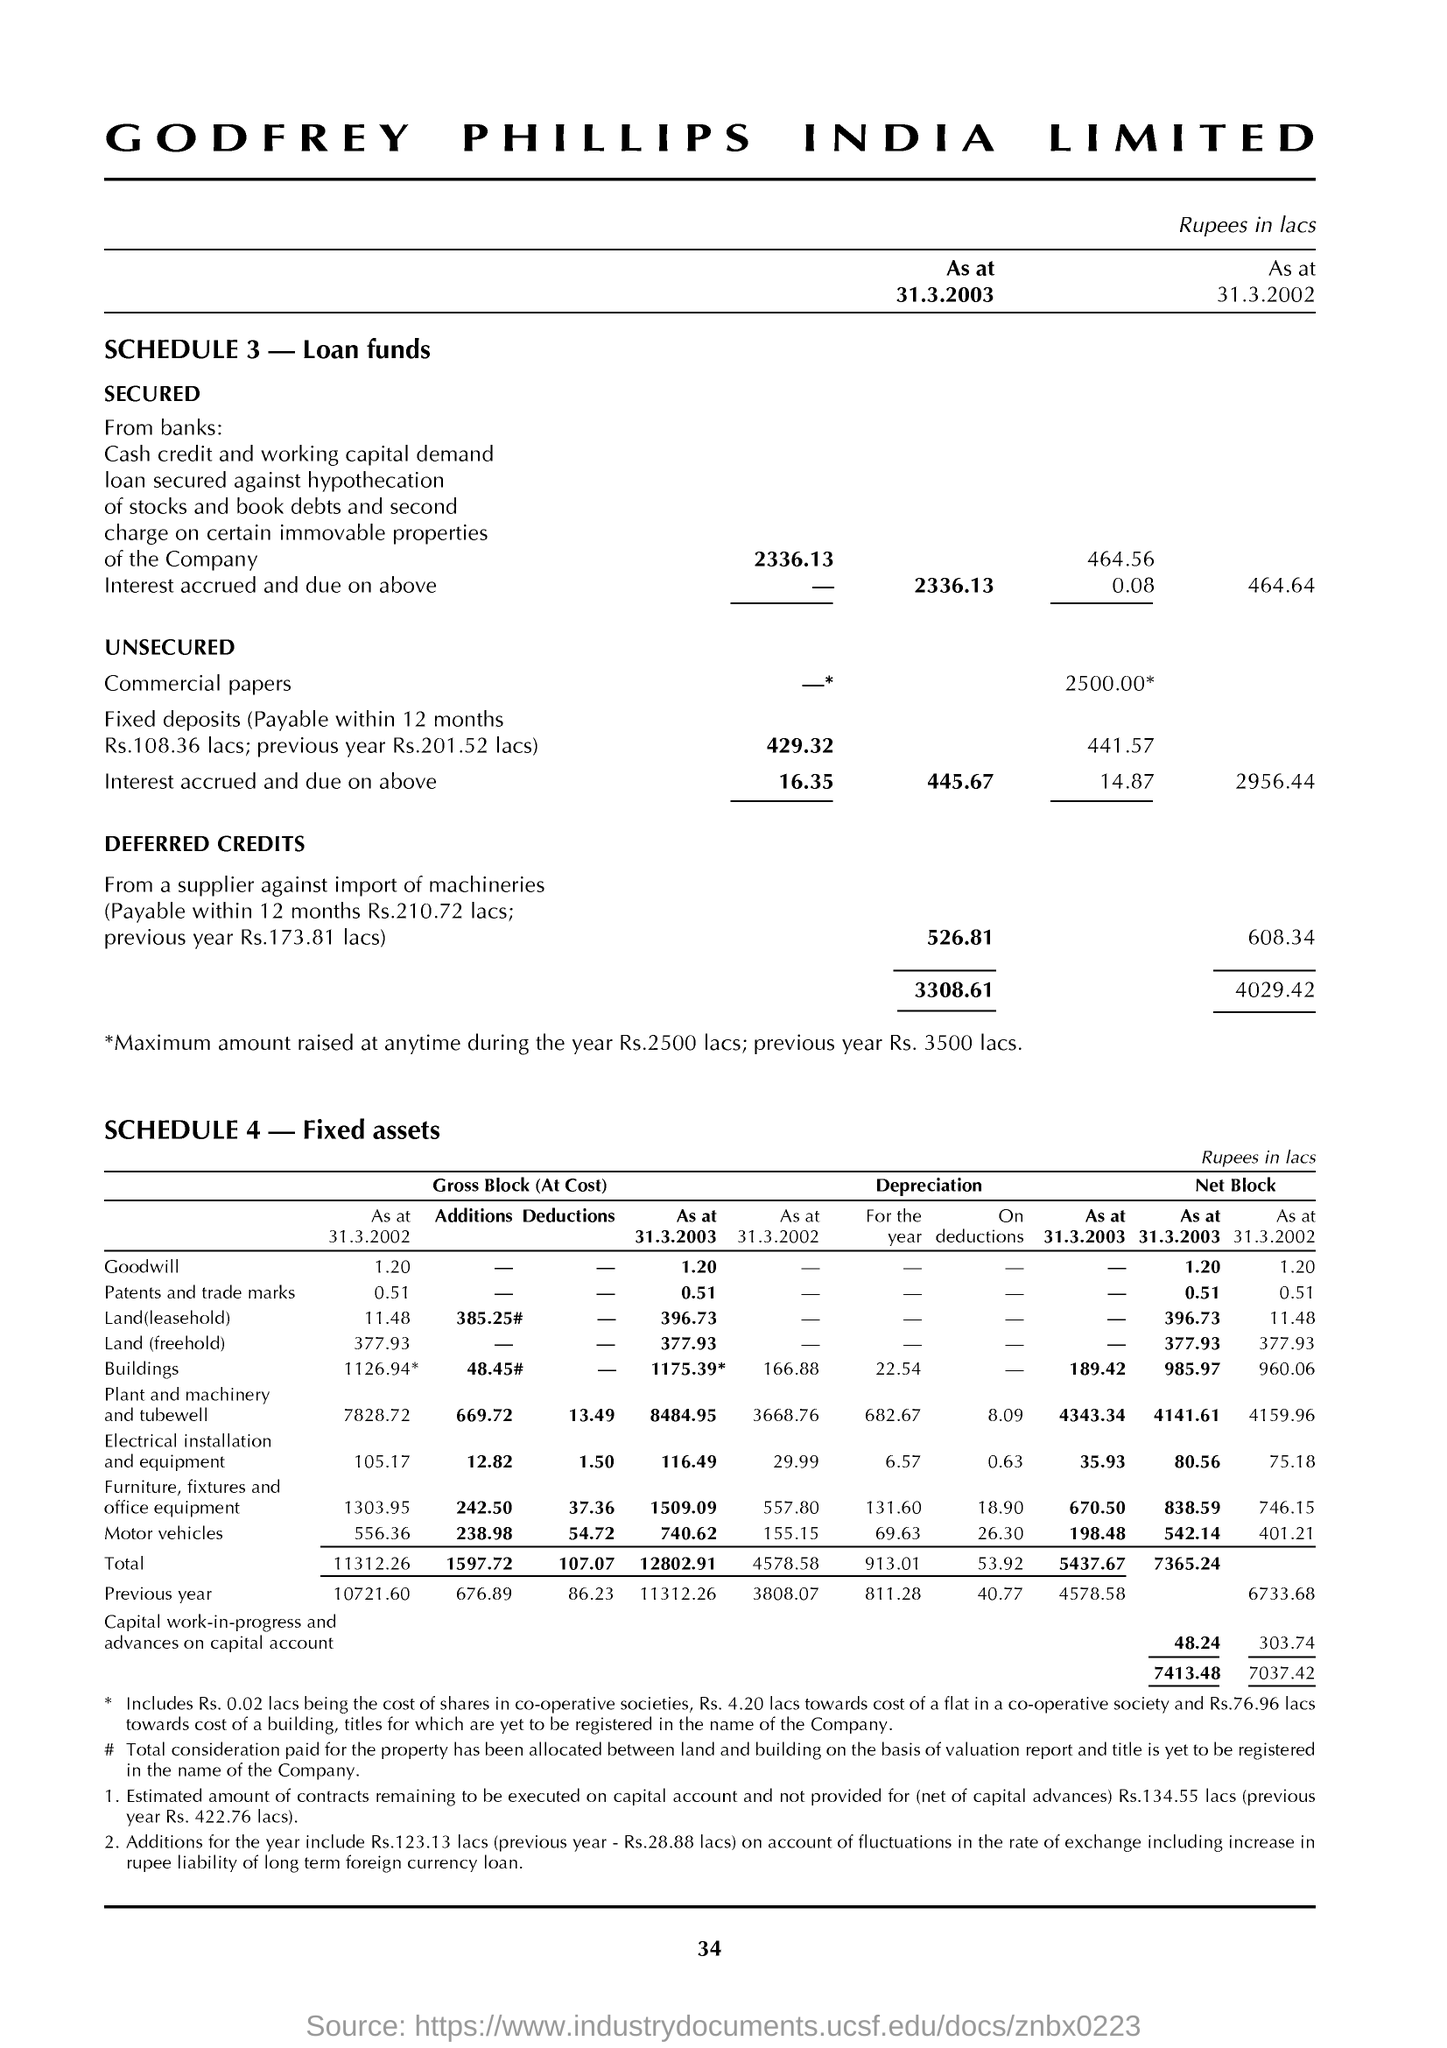What is written in the Letter Head ?
Offer a very short reply. Godfrey phillips india limited. What is showing SCHEDULE 3 ?
Offer a terse response. Loan funds. 